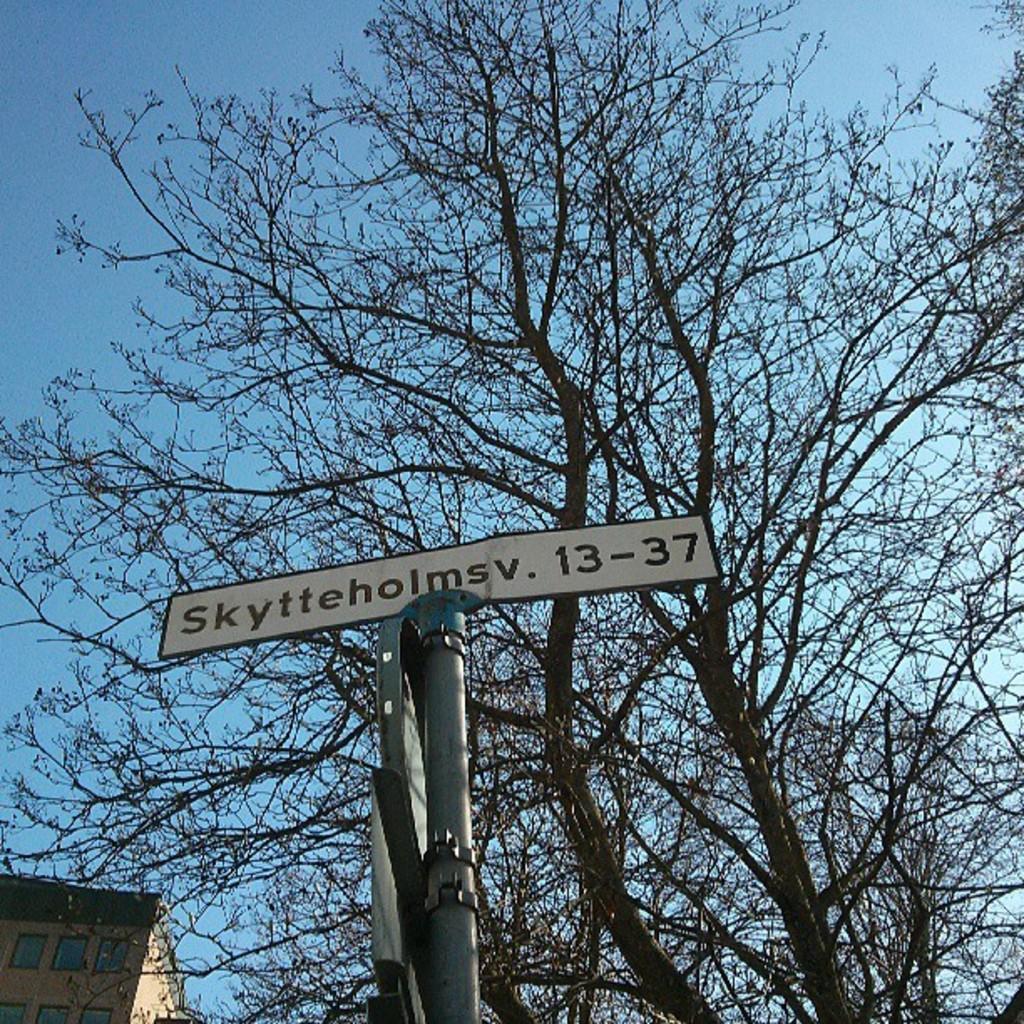Please provide a concise description of this image. In this image there are trees and we can see a pole. There is a board. On the left there is a building. In the background there is sky. 